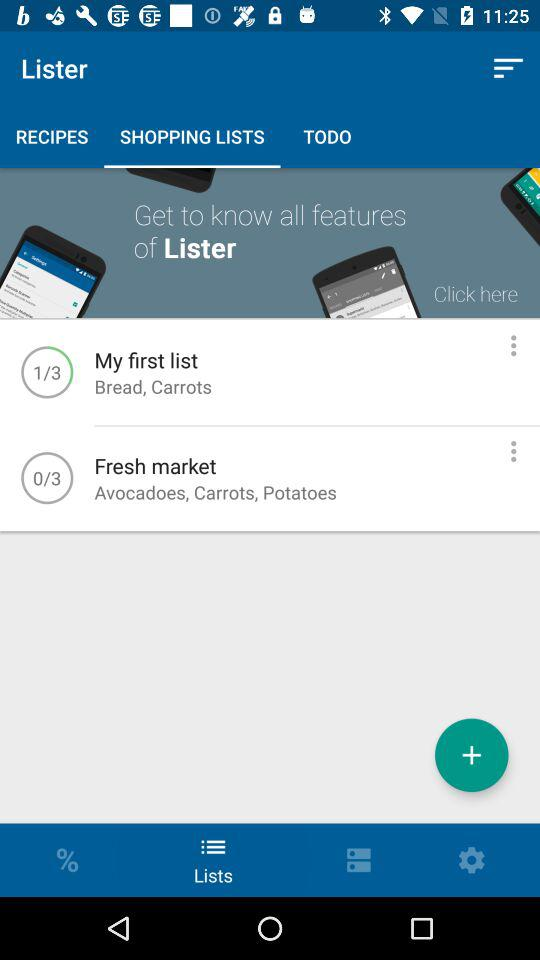On which page Fresh Market is the person currently?
When the provided information is insufficient, respond with <no answer>. <no answer> 